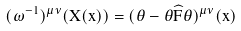Convert formula to latex. <formula><loc_0><loc_0><loc_500><loc_500>( \omega ^ { - 1 } ) ^ { \mu \nu } ( X ( x ) ) = ( \theta - \theta \widehat { F } \theta ) ^ { \mu \nu } ( x )</formula> 